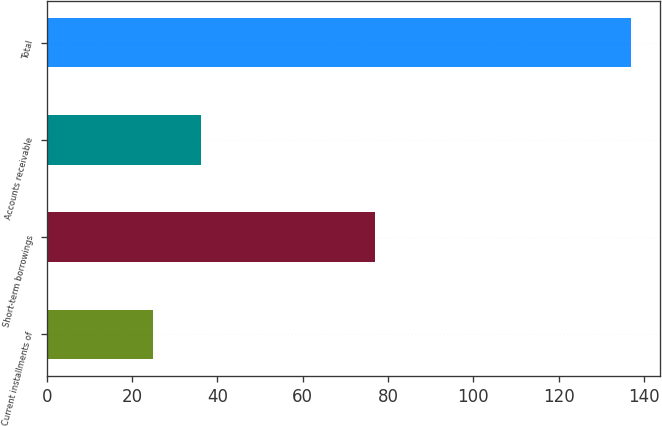Convert chart to OTSL. <chart><loc_0><loc_0><loc_500><loc_500><bar_chart><fcel>Current installments of<fcel>Short-term borrowings<fcel>Accounts receivable<fcel>Total<nl><fcel>25<fcel>77<fcel>36.2<fcel>137<nl></chart> 